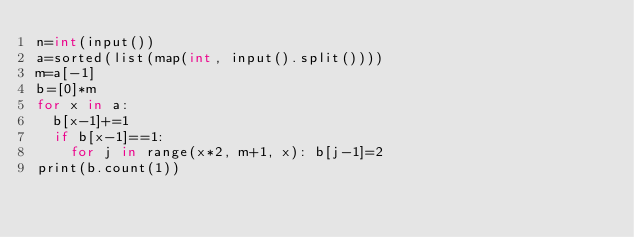<code> <loc_0><loc_0><loc_500><loc_500><_Cython_>n=int(input())
a=sorted(list(map(int, input().split())))
m=a[-1]
b=[0]*m
for x in a:
  b[x-1]+=1
  if b[x-1]==1:
    for j in range(x*2, m+1, x): b[j-1]=2
print(b.count(1))</code> 